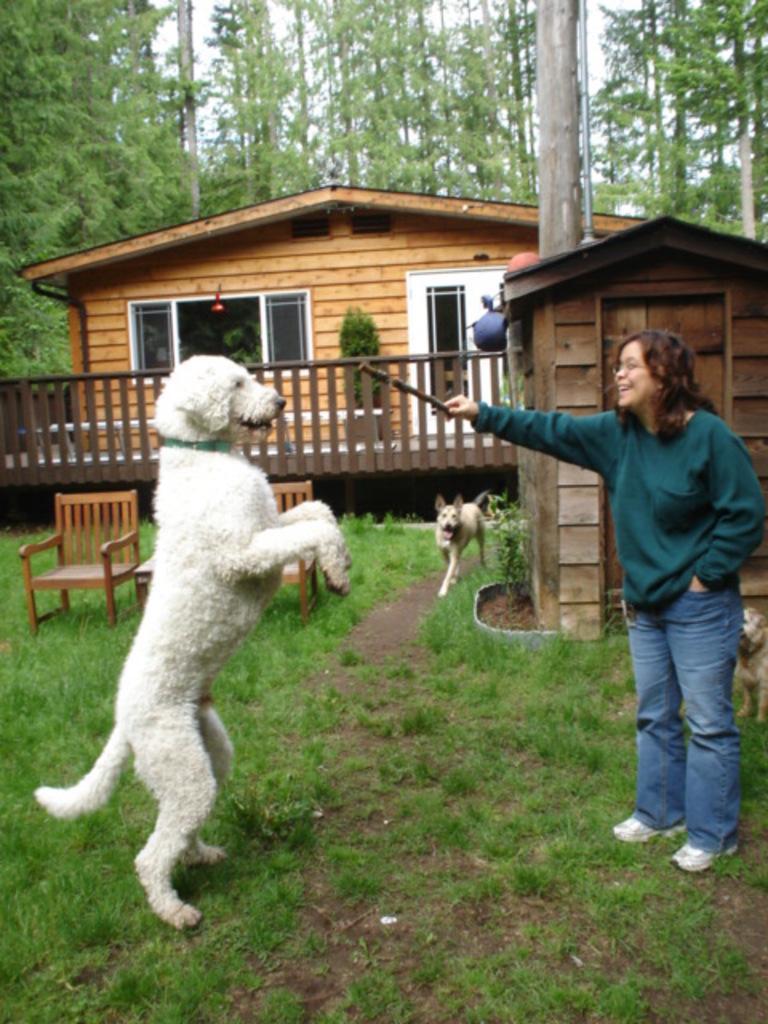How would you summarize this image in a sentence or two? In the center of the image there is a dog standing on legs. There is a lady holding a stick in her hand. In the background of the image there is a house. There are trees. At the bottom of the image there is grass. There is another dog in the image. 